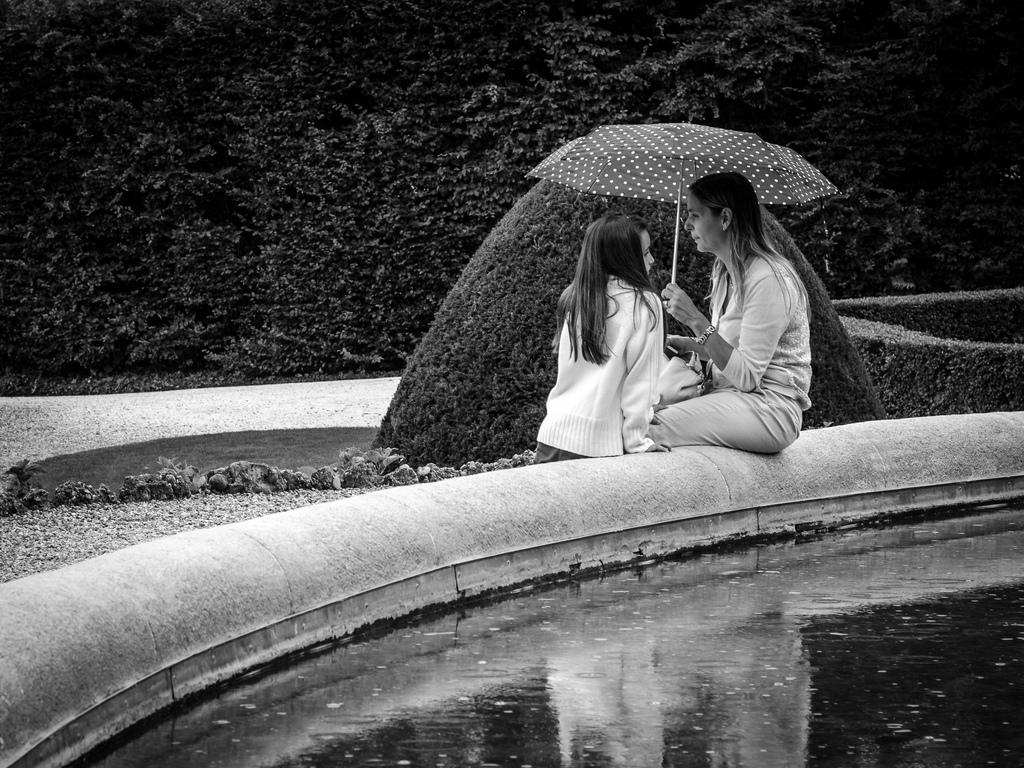How many people are in the image? There are two women in the image. What is one of the women holding? One of the women is holding an umbrella. What can be seen in the background of the image? There are trees visible in the background of the image. What type of reward is the dog receiving from the plane in the image? There is no dog or plane present in the image, so it is not possible to answer that question. 